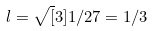Convert formula to latex. <formula><loc_0><loc_0><loc_500><loc_500>l = \sqrt { [ } 3 ] { 1 / 2 7 } = 1 / 3</formula> 